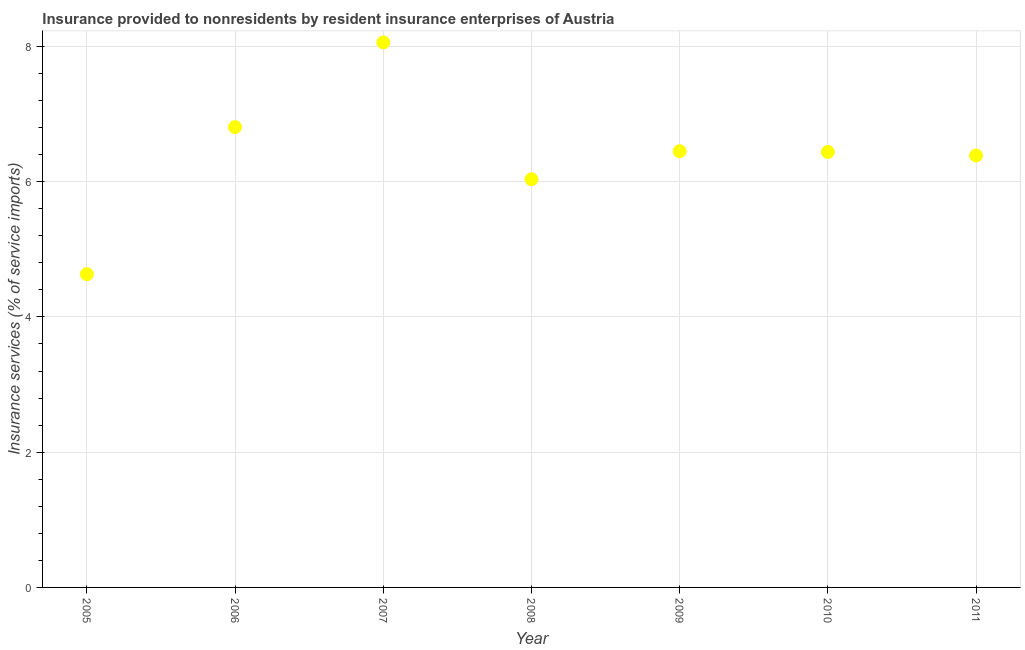What is the insurance and financial services in 2009?
Offer a terse response. 6.45. Across all years, what is the maximum insurance and financial services?
Ensure brevity in your answer.  8.06. Across all years, what is the minimum insurance and financial services?
Keep it short and to the point. 4.63. In which year was the insurance and financial services maximum?
Provide a short and direct response. 2007. In which year was the insurance and financial services minimum?
Give a very brief answer. 2005. What is the sum of the insurance and financial services?
Offer a terse response. 44.81. What is the difference between the insurance and financial services in 2007 and 2010?
Keep it short and to the point. 1.62. What is the average insurance and financial services per year?
Your answer should be very brief. 6.4. What is the median insurance and financial services?
Provide a short and direct response. 6.44. Do a majority of the years between 2011 and 2007 (inclusive) have insurance and financial services greater than 6.4 %?
Ensure brevity in your answer.  Yes. What is the ratio of the insurance and financial services in 2005 to that in 2008?
Your answer should be compact. 0.77. Is the insurance and financial services in 2005 less than that in 2007?
Make the answer very short. Yes. Is the difference between the insurance and financial services in 2007 and 2009 greater than the difference between any two years?
Provide a succinct answer. No. What is the difference between the highest and the second highest insurance and financial services?
Provide a succinct answer. 1.25. Is the sum of the insurance and financial services in 2010 and 2011 greater than the maximum insurance and financial services across all years?
Your answer should be compact. Yes. What is the difference between the highest and the lowest insurance and financial services?
Ensure brevity in your answer.  3.43. In how many years, is the insurance and financial services greater than the average insurance and financial services taken over all years?
Ensure brevity in your answer.  4. Does the insurance and financial services monotonically increase over the years?
Provide a short and direct response. No. Does the graph contain any zero values?
Offer a very short reply. No. Does the graph contain grids?
Provide a short and direct response. Yes. What is the title of the graph?
Make the answer very short. Insurance provided to nonresidents by resident insurance enterprises of Austria. What is the label or title of the X-axis?
Offer a terse response. Year. What is the label or title of the Y-axis?
Your response must be concise. Insurance services (% of service imports). What is the Insurance services (% of service imports) in 2005?
Provide a succinct answer. 4.63. What is the Insurance services (% of service imports) in 2006?
Provide a succinct answer. 6.81. What is the Insurance services (% of service imports) in 2007?
Your answer should be very brief. 8.06. What is the Insurance services (% of service imports) in 2008?
Provide a short and direct response. 6.04. What is the Insurance services (% of service imports) in 2009?
Provide a short and direct response. 6.45. What is the Insurance services (% of service imports) in 2010?
Keep it short and to the point. 6.44. What is the Insurance services (% of service imports) in 2011?
Give a very brief answer. 6.39. What is the difference between the Insurance services (% of service imports) in 2005 and 2006?
Offer a very short reply. -2.18. What is the difference between the Insurance services (% of service imports) in 2005 and 2007?
Ensure brevity in your answer.  -3.43. What is the difference between the Insurance services (% of service imports) in 2005 and 2008?
Provide a short and direct response. -1.4. What is the difference between the Insurance services (% of service imports) in 2005 and 2009?
Provide a succinct answer. -1.82. What is the difference between the Insurance services (% of service imports) in 2005 and 2010?
Offer a terse response. -1.81. What is the difference between the Insurance services (% of service imports) in 2005 and 2011?
Provide a short and direct response. -1.76. What is the difference between the Insurance services (% of service imports) in 2006 and 2007?
Provide a succinct answer. -1.25. What is the difference between the Insurance services (% of service imports) in 2006 and 2008?
Ensure brevity in your answer.  0.77. What is the difference between the Insurance services (% of service imports) in 2006 and 2009?
Your answer should be very brief. 0.36. What is the difference between the Insurance services (% of service imports) in 2006 and 2010?
Give a very brief answer. 0.37. What is the difference between the Insurance services (% of service imports) in 2006 and 2011?
Your answer should be very brief. 0.42. What is the difference between the Insurance services (% of service imports) in 2007 and 2008?
Keep it short and to the point. 2.02. What is the difference between the Insurance services (% of service imports) in 2007 and 2009?
Your answer should be very brief. 1.61. What is the difference between the Insurance services (% of service imports) in 2007 and 2010?
Keep it short and to the point. 1.62. What is the difference between the Insurance services (% of service imports) in 2007 and 2011?
Make the answer very short. 1.67. What is the difference between the Insurance services (% of service imports) in 2008 and 2009?
Provide a short and direct response. -0.42. What is the difference between the Insurance services (% of service imports) in 2008 and 2010?
Keep it short and to the point. -0.4. What is the difference between the Insurance services (% of service imports) in 2008 and 2011?
Keep it short and to the point. -0.35. What is the difference between the Insurance services (% of service imports) in 2009 and 2010?
Offer a very short reply. 0.01. What is the difference between the Insurance services (% of service imports) in 2009 and 2011?
Your answer should be compact. 0.06. What is the difference between the Insurance services (% of service imports) in 2010 and 2011?
Your answer should be compact. 0.05. What is the ratio of the Insurance services (% of service imports) in 2005 to that in 2006?
Offer a terse response. 0.68. What is the ratio of the Insurance services (% of service imports) in 2005 to that in 2007?
Make the answer very short. 0.57. What is the ratio of the Insurance services (% of service imports) in 2005 to that in 2008?
Your answer should be compact. 0.77. What is the ratio of the Insurance services (% of service imports) in 2005 to that in 2009?
Your response must be concise. 0.72. What is the ratio of the Insurance services (% of service imports) in 2005 to that in 2010?
Ensure brevity in your answer.  0.72. What is the ratio of the Insurance services (% of service imports) in 2005 to that in 2011?
Offer a very short reply. 0.72. What is the ratio of the Insurance services (% of service imports) in 2006 to that in 2007?
Your answer should be very brief. 0.84. What is the ratio of the Insurance services (% of service imports) in 2006 to that in 2008?
Give a very brief answer. 1.13. What is the ratio of the Insurance services (% of service imports) in 2006 to that in 2009?
Provide a succinct answer. 1.05. What is the ratio of the Insurance services (% of service imports) in 2006 to that in 2010?
Provide a short and direct response. 1.06. What is the ratio of the Insurance services (% of service imports) in 2006 to that in 2011?
Provide a short and direct response. 1.07. What is the ratio of the Insurance services (% of service imports) in 2007 to that in 2008?
Offer a terse response. 1.33. What is the ratio of the Insurance services (% of service imports) in 2007 to that in 2009?
Offer a very short reply. 1.25. What is the ratio of the Insurance services (% of service imports) in 2007 to that in 2010?
Make the answer very short. 1.25. What is the ratio of the Insurance services (% of service imports) in 2007 to that in 2011?
Your answer should be compact. 1.26. What is the ratio of the Insurance services (% of service imports) in 2008 to that in 2009?
Your answer should be very brief. 0.94. What is the ratio of the Insurance services (% of service imports) in 2008 to that in 2010?
Provide a succinct answer. 0.94. What is the ratio of the Insurance services (% of service imports) in 2008 to that in 2011?
Ensure brevity in your answer.  0.94. What is the ratio of the Insurance services (% of service imports) in 2009 to that in 2010?
Ensure brevity in your answer.  1. What is the ratio of the Insurance services (% of service imports) in 2009 to that in 2011?
Give a very brief answer. 1.01. What is the ratio of the Insurance services (% of service imports) in 2010 to that in 2011?
Provide a succinct answer. 1.01. 